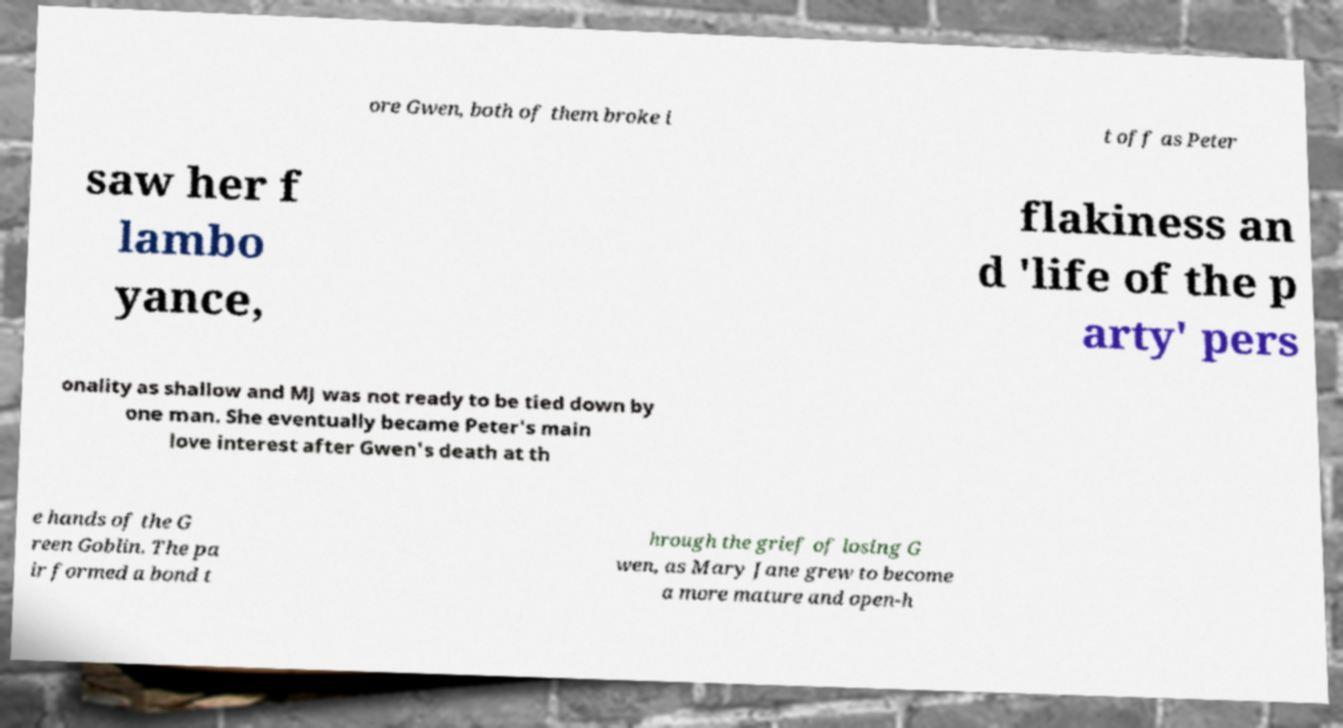Could you extract and type out the text from this image? ore Gwen, both of them broke i t off as Peter saw her f lambo yance, flakiness an d 'life of the p arty' pers onality as shallow and MJ was not ready to be tied down by one man. She eventually became Peter's main love interest after Gwen's death at th e hands of the G reen Goblin. The pa ir formed a bond t hrough the grief of losing G wen, as Mary Jane grew to become a more mature and open-h 